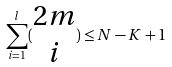<formula> <loc_0><loc_0><loc_500><loc_500>\sum _ { i = 1 } ^ { l } ( \begin{matrix} 2 m \\ i \end{matrix} ) \leq N - K + 1</formula> 